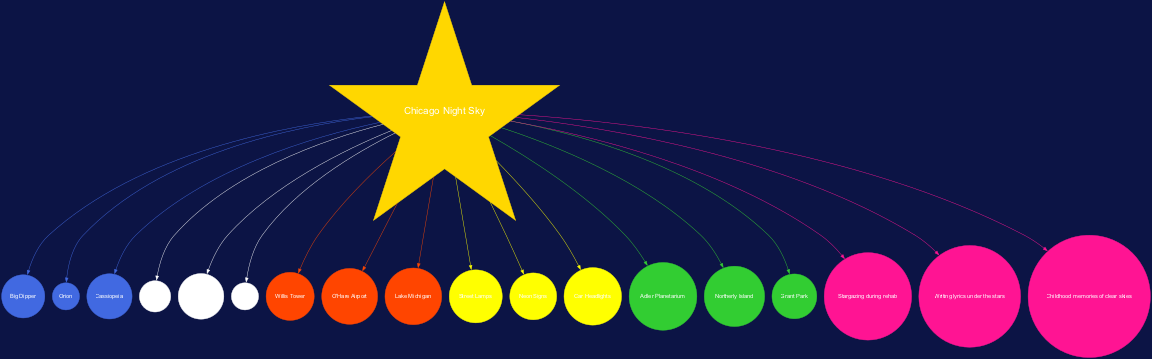What is the central node of the diagram? The central node, labeled as "Chicago Night Sky," serves as the primary focal point in the diagram. It connects various elements related to the night sky above Chicago.
Answer: Chicago Night Sky How many constellations are shown in the diagram? The diagram lists three constellations, which are connected to the central node. By counting these constellations, we find that there are three.
Answer: 3 Which constellation is associated with the star Betelgeuse? Betelgeuse is directly linked to the constellation Orion. The association is evident based on the layout in the diagram.
Answer: Orion What is one source of light pollution mentioned in the diagram? One source of light pollution listed in the diagram is "Street Lamps." This indicates urban light pollution that impacts stargazing.
Answer: Street Lamps Which star is indicated as the brightest in the night sky? Sirius is described in the diagram as the brightest star, highlighted among other stellar components of the night sky.
Answer: Sirius From which location is it best to view the stars according to the diagram? The diagram points to "Adler Planetarium" as a prime viewing location for stargazing in Chicago, making it a favored spot.
Answer: Adler Planetarium How many personal connections are noted in the diagram? The diagram lists three personal connections related to stargazing experiences. By identifying these connections visually, we see there are three.
Answer: 3 Which urban feature is shown closest to Lake Michigan? The urban feature "Grant Park" is illustrated as being situated near Lake Michigan in the diagram, showcasing a geographical connection.
Answer: Grant Park What color is used to represent the constellations in the diagram? The constellations are represented in royal blue, which is the specific color used for those nodes in the diagram, creating visual consistency.
Answer: Royal Blue 